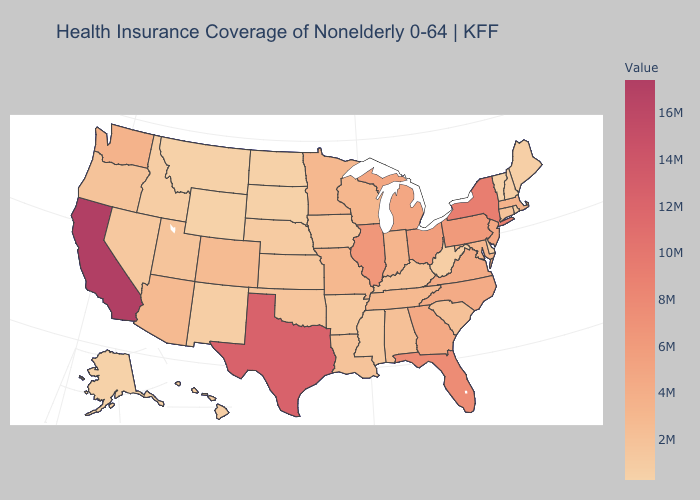Does the map have missing data?
Quick response, please. No. Does the map have missing data?
Give a very brief answer. No. Does Nevada have the lowest value in the West?
Quick response, please. No. Which states hav the highest value in the West?
Be succinct. California. Does California have the highest value in the USA?
Quick response, please. Yes. 